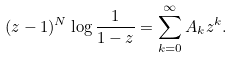<formula> <loc_0><loc_0><loc_500><loc_500>( z - 1 ) ^ { N } \log \frac { 1 } { 1 - z } & = \sum _ { k = 0 } ^ { \infty } A _ { k } z ^ { k } .</formula> 